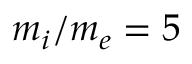Convert formula to latex. <formula><loc_0><loc_0><loc_500><loc_500>m _ { i } / m _ { e } = 5</formula> 